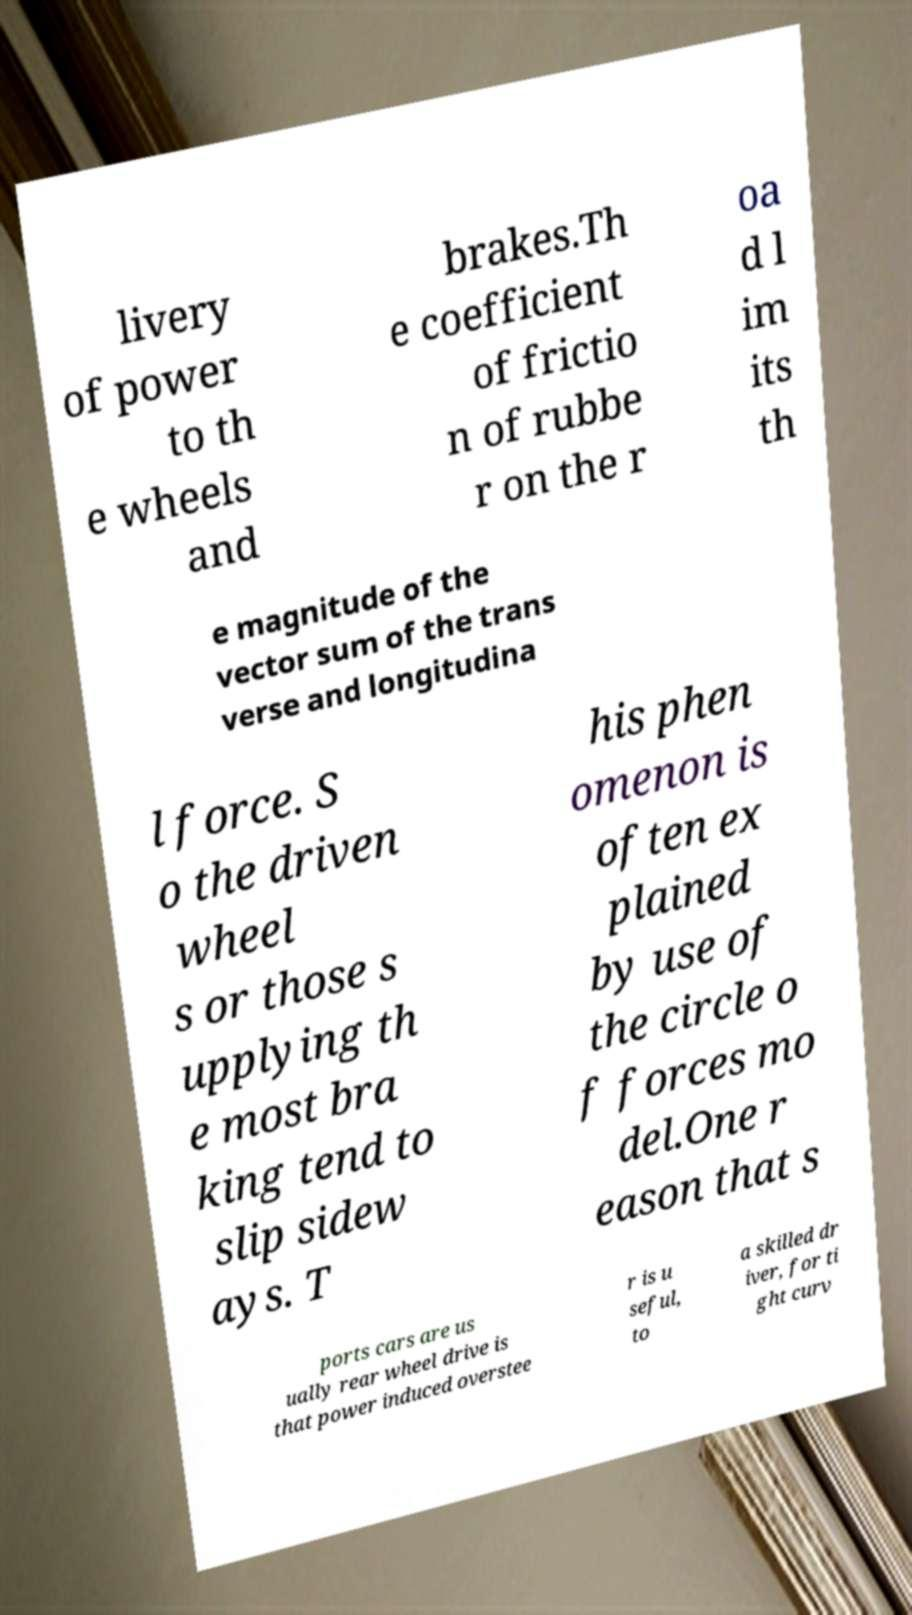Can you accurately transcribe the text from the provided image for me? livery of power to th e wheels and brakes.Th e coefficient of frictio n of rubbe r on the r oa d l im its th e magnitude of the vector sum of the trans verse and longitudina l force. S o the driven wheel s or those s upplying th e most bra king tend to slip sidew ays. T his phen omenon is often ex plained by use of the circle o f forces mo del.One r eason that s ports cars are us ually rear wheel drive is that power induced overstee r is u seful, to a skilled dr iver, for ti ght curv 